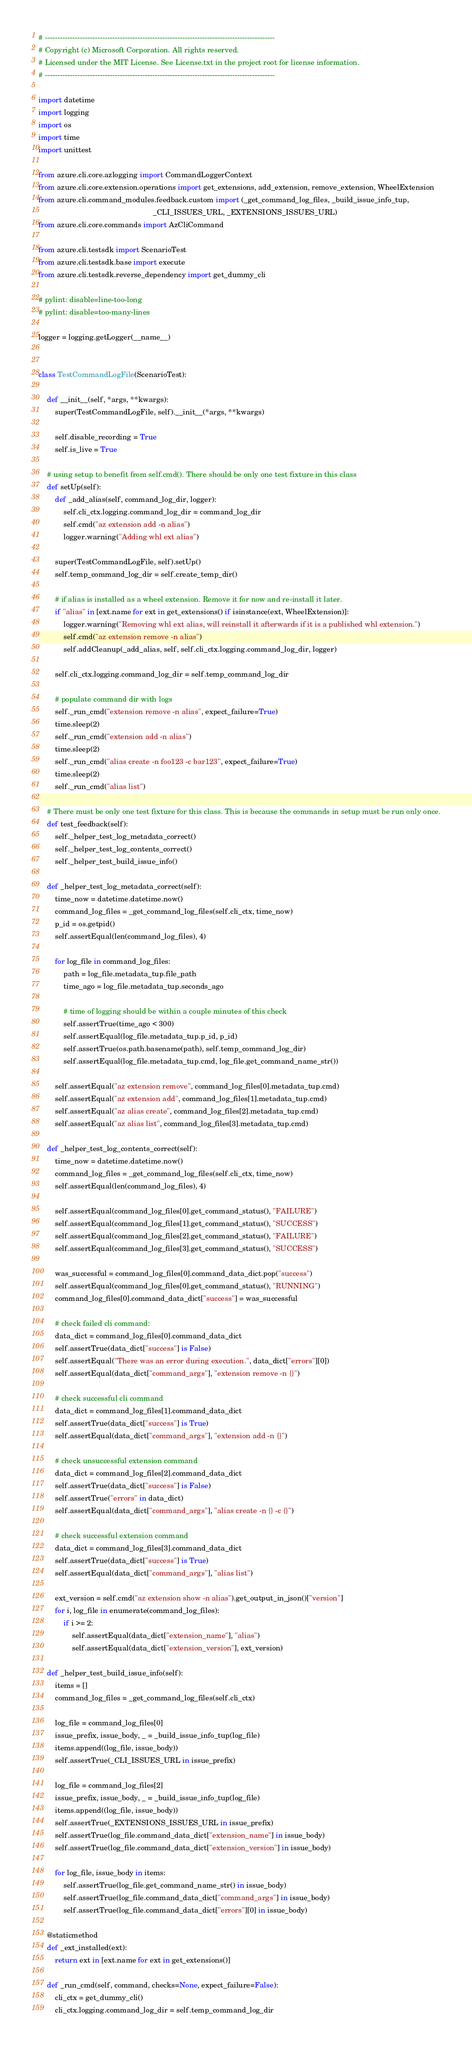Convert code to text. <code><loc_0><loc_0><loc_500><loc_500><_Python_># --------------------------------------------------------------------------------------------
# Copyright (c) Microsoft Corporation. All rights reserved.
# Licensed under the MIT License. See License.txt in the project root for license information.
# --------------------------------------------------------------------------------------------

import datetime
import logging
import os
import time
import unittest

from azure.cli.core.azlogging import CommandLoggerContext
from azure.cli.core.extension.operations import get_extensions, add_extension, remove_extension, WheelExtension
from azure.cli.command_modules.feedback.custom import (_get_command_log_files, _build_issue_info_tup,
                                                       _CLI_ISSUES_URL, _EXTENSIONS_ISSUES_URL)
from azure.cli.core.commands import AzCliCommand

from azure.cli.testsdk import ScenarioTest
from azure.cli.testsdk.base import execute
from azure.cli.testsdk.reverse_dependency import get_dummy_cli

# pylint: disable=line-too-long
# pylint: disable=too-many-lines

logger = logging.getLogger(__name__)


class TestCommandLogFile(ScenarioTest):

    def __init__(self, *args, **kwargs):
        super(TestCommandLogFile, self).__init__(*args, **kwargs)

        self.disable_recording = True
        self.is_live = True

    # using setup to benefit from self.cmd(). There should be only one test fixture in this class
    def setUp(self):
        def _add_alias(self, command_log_dir, logger):
            self.cli_ctx.logging.command_log_dir = command_log_dir
            self.cmd("az extension add -n alias")
            logger.warning("Adding whl ext alias")

        super(TestCommandLogFile, self).setUp()
        self.temp_command_log_dir = self.create_temp_dir()

        # if alias is installed as a wheel extension. Remove it for now and re-install it later.
        if "alias" in [ext.name for ext in get_extensions() if isinstance(ext, WheelExtension)]:
            logger.warning("Removing whl ext alias, will reinstall it afterwards if it is a published whl extension.")
            self.cmd("az extension remove -n alias")
            self.addCleanup(_add_alias, self, self.cli_ctx.logging.command_log_dir, logger)

        self.cli_ctx.logging.command_log_dir = self.temp_command_log_dir

        # populate command dir with logs
        self._run_cmd("extension remove -n alias", expect_failure=True)
        time.sleep(2)
        self._run_cmd("extension add -n alias")
        time.sleep(2)
        self._run_cmd("alias create -n foo123 -c bar123", expect_failure=True)
        time.sleep(2)
        self._run_cmd("alias list")

    # There must be only one test fixture for this class. This is because the commands in setup must be run only once.
    def test_feedback(self):
        self._helper_test_log_metadata_correct()
        self._helper_test_log_contents_correct()
        self._helper_test_build_issue_info()

    def _helper_test_log_metadata_correct(self):
        time_now = datetime.datetime.now()
        command_log_files = _get_command_log_files(self.cli_ctx, time_now)
        p_id = os.getpid()
        self.assertEqual(len(command_log_files), 4)

        for log_file in command_log_files:
            path = log_file.metadata_tup.file_path
            time_ago = log_file.metadata_tup.seconds_ago

            # time of logging should be within a couple minutes of this check
            self.assertTrue(time_ago < 300)
            self.assertEqual(log_file.metadata_tup.p_id, p_id)
            self.assertTrue(os.path.basename(path), self.temp_command_log_dir)
            self.assertEqual(log_file.metadata_tup.cmd, log_file.get_command_name_str())

        self.assertEqual("az extension remove", command_log_files[0].metadata_tup.cmd)
        self.assertEqual("az extension add", command_log_files[1].metadata_tup.cmd)
        self.assertEqual("az alias create", command_log_files[2].metadata_tup.cmd)
        self.assertEqual("az alias list", command_log_files[3].metadata_tup.cmd)

    def _helper_test_log_contents_correct(self):
        time_now = datetime.datetime.now()
        command_log_files = _get_command_log_files(self.cli_ctx, time_now)
        self.assertEqual(len(command_log_files), 4)

        self.assertEqual(command_log_files[0].get_command_status(), "FAILURE")
        self.assertEqual(command_log_files[1].get_command_status(), "SUCCESS")
        self.assertEqual(command_log_files[2].get_command_status(), "FAILURE")
        self.assertEqual(command_log_files[3].get_command_status(), "SUCCESS")

        was_successful = command_log_files[0].command_data_dict.pop("success")
        self.assertEqual(command_log_files[0].get_command_status(), "RUNNING")
        command_log_files[0].command_data_dict["success"] = was_successful

        # check failed cli command:
        data_dict = command_log_files[0].command_data_dict
        self.assertTrue(data_dict["success"] is False)
        self.assertEqual("There was an error during execution.", data_dict["errors"][0])
        self.assertEqual(data_dict["command_args"], "extension remove -n {}")

        # check successful cli command
        data_dict = command_log_files[1].command_data_dict
        self.assertTrue(data_dict["success"] is True)
        self.assertEqual(data_dict["command_args"], "extension add -n {}")

        # check unsuccessful extension command
        data_dict = command_log_files[2].command_data_dict
        self.assertTrue(data_dict["success"] is False)
        self.assertTrue("errors" in data_dict)
        self.assertEqual(data_dict["command_args"], "alias create -n {} -c {}")

        # check successful extension command
        data_dict = command_log_files[3].command_data_dict
        self.assertTrue(data_dict["success"] is True)
        self.assertEqual(data_dict["command_args"], "alias list")

        ext_version = self.cmd("az extension show -n alias").get_output_in_json()["version"]
        for i, log_file in enumerate(command_log_files):
            if i >= 2:
                self.assertEqual(data_dict["extension_name"], "alias")
                self.assertEqual(data_dict["extension_version"], ext_version)

    def _helper_test_build_issue_info(self):
        items = []
        command_log_files = _get_command_log_files(self.cli_ctx)

        log_file = command_log_files[0]
        issue_prefix, issue_body, _ = _build_issue_info_tup(log_file)
        items.append((log_file, issue_body))
        self.assertTrue(_CLI_ISSUES_URL in issue_prefix)

        log_file = command_log_files[2]
        issue_prefix, issue_body, _ = _build_issue_info_tup(log_file)
        items.append((log_file, issue_body))
        self.assertTrue(_EXTENSIONS_ISSUES_URL in issue_prefix)
        self.assertTrue(log_file.command_data_dict["extension_name"] in issue_body)
        self.assertTrue(log_file.command_data_dict["extension_version"] in issue_body)

        for log_file, issue_body in items:
            self.assertTrue(log_file.get_command_name_str() in issue_body)
            self.assertTrue(log_file.command_data_dict["command_args"] in issue_body)
            self.assertTrue(log_file.command_data_dict["errors"][0] in issue_body)

    @staticmethod
    def _ext_installed(ext):
        return ext in [ext.name for ext in get_extensions()]

    def _run_cmd(self, command, checks=None, expect_failure=False):
        cli_ctx = get_dummy_cli()
        cli_ctx.logging.command_log_dir = self.temp_command_log_dir
</code> 